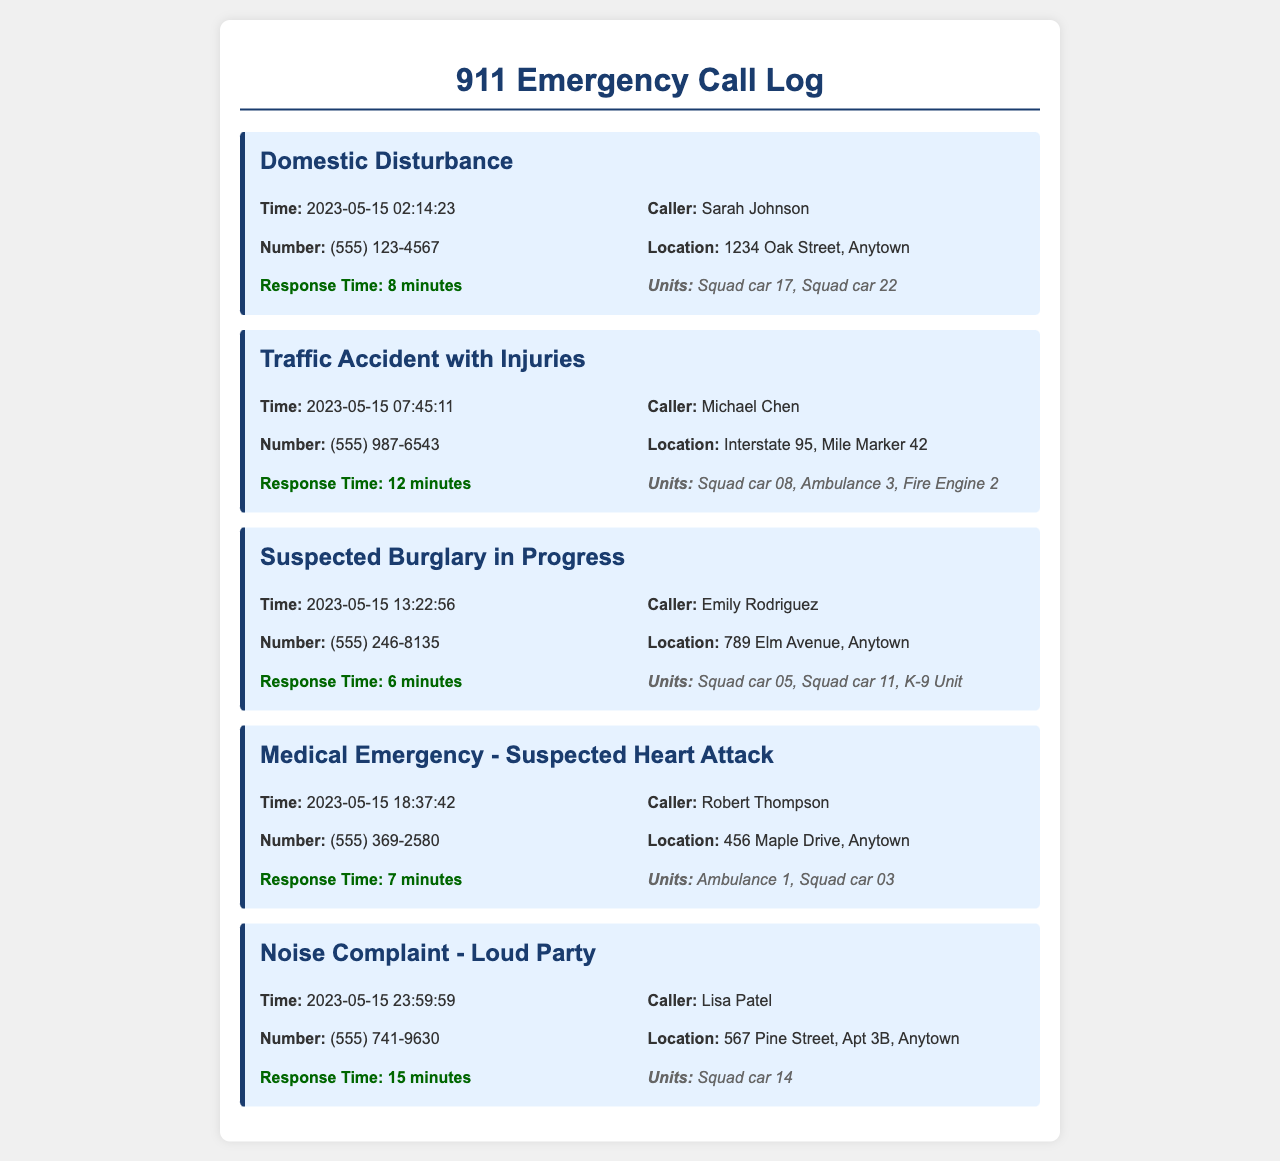What is the time of the domestic disturbance call? The domestic disturbance call was made at 2023-05-15 02:14:23.
Answer: 2023-05-15 02:14:23 Who made the traffic accident call? The traffic accident call was made by Michael Chen.
Answer: Michael Chen What was the response time for the suspected burglary call? The response time for the suspected burglary in progress was 6 minutes.
Answer: 6 minutes How many units were dispatched for the medical emergency? For the medical emergency, two units were dispatched: Ambulance 1 and Squad car 03.
Answer: Ambulance 1, Squad car 03 Which call occurred last in the log? The last call in the log was a noise complaint about a loud party.
Answer: Noise Complaint - Loud Party What is the location of the traffic accident? The location of the traffic accident is Interstate 95, Mile Marker 42.
Answer: Interstate 95, Mile Marker 42 How many calls involved medical emergencies? There were two calls that involved medical emergencies, one suspected heart attack and the other call details unspecified.
Answer: 1 What type of emergency was reported at 18:37:42? At 18:37:42, a medical emergency - suspected heart attack was reported.
Answer: Medical Emergency - Suspected Heart Attack 